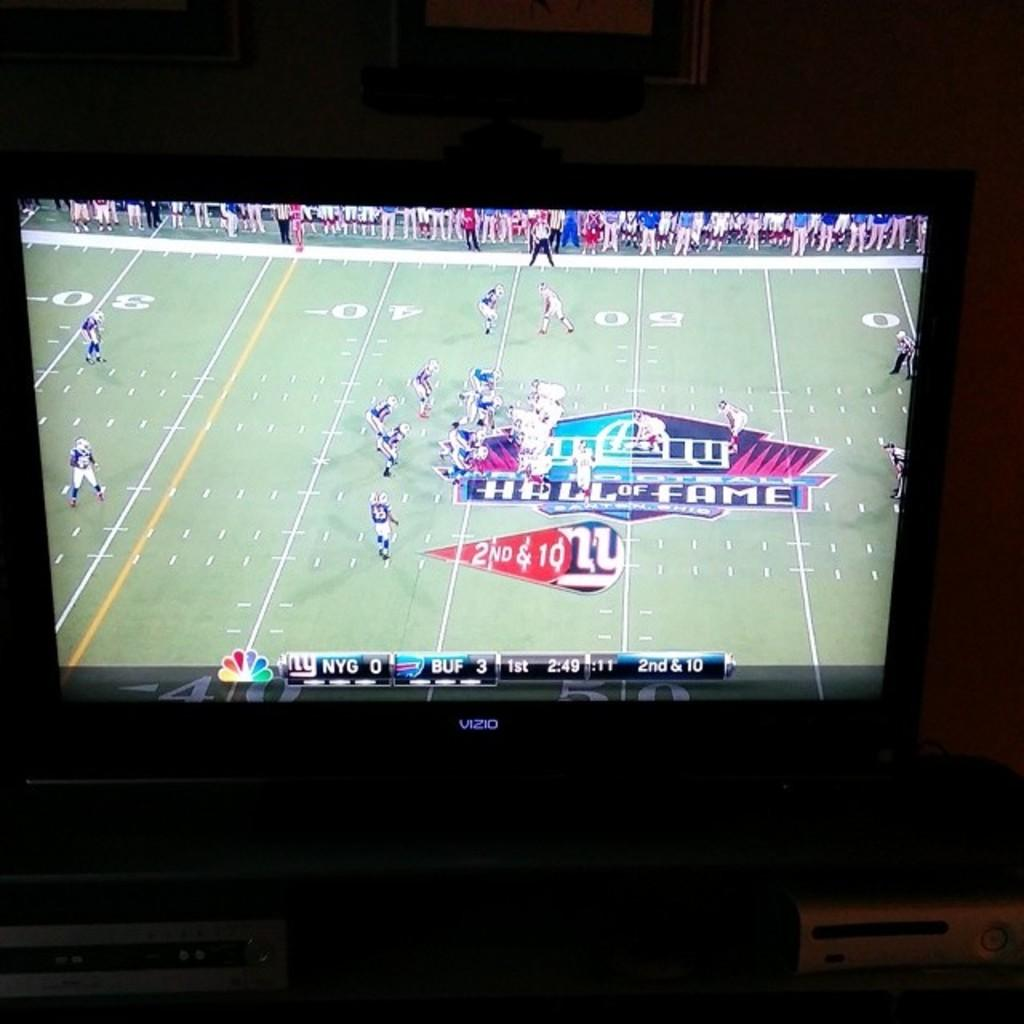<image>
Summarize the visual content of the image. tv screen showing nfl game between new york giants and buffalo bills 